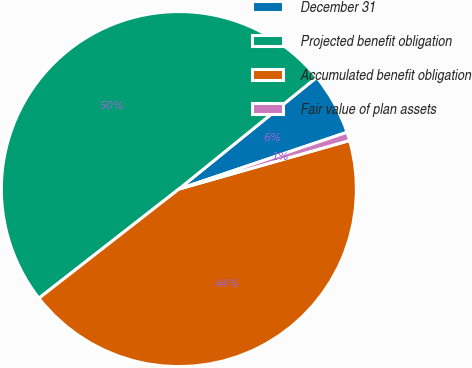Convert chart to OTSL. <chart><loc_0><loc_0><loc_500><loc_500><pie_chart><fcel>December 31<fcel>Projected benefit obligation<fcel>Accumulated benefit obligation<fcel>Fair value of plan assets<nl><fcel>5.66%<fcel>49.7%<fcel>43.87%<fcel>0.77%<nl></chart> 